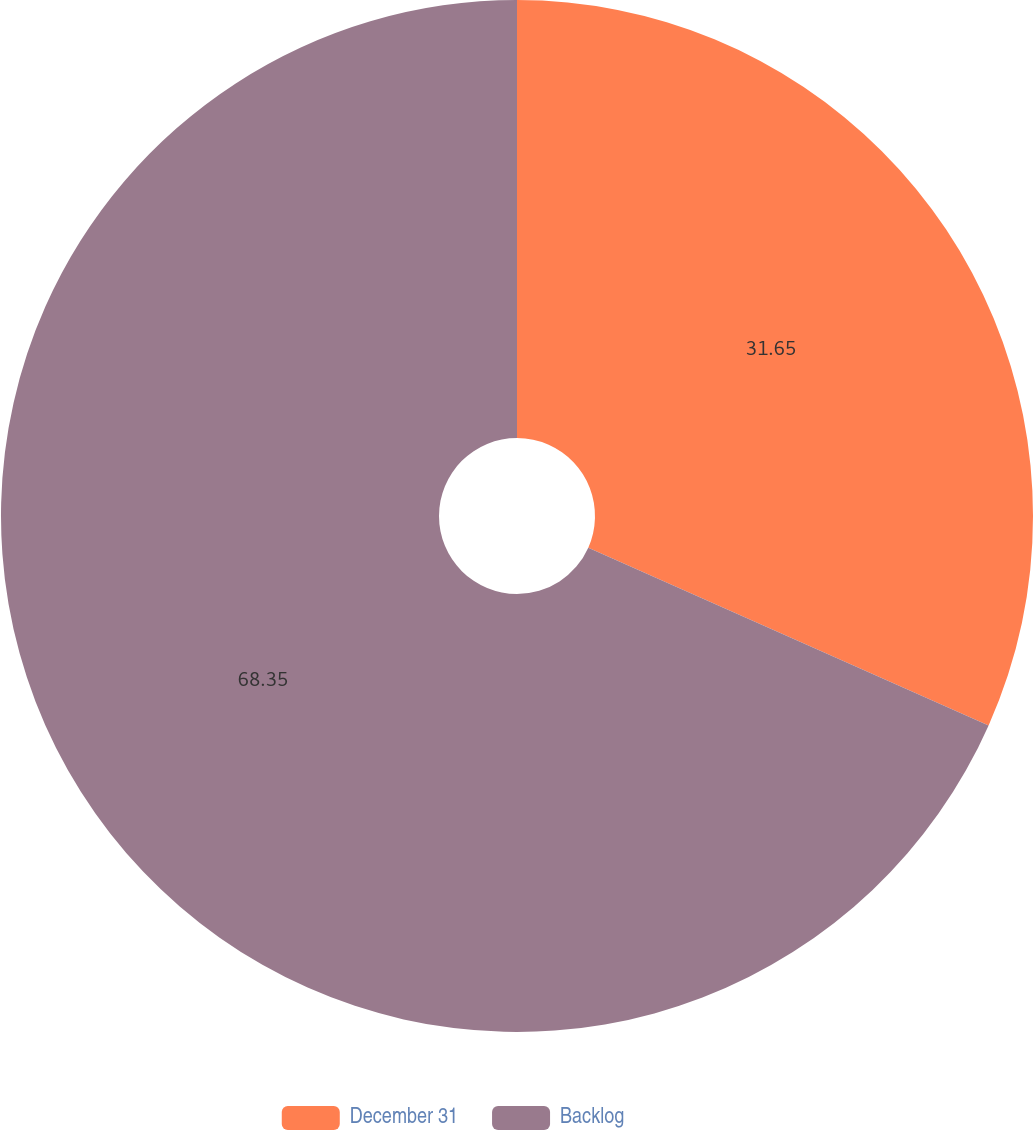<chart> <loc_0><loc_0><loc_500><loc_500><pie_chart><fcel>December 31<fcel>Backlog<nl><fcel>31.65%<fcel>68.35%<nl></chart> 